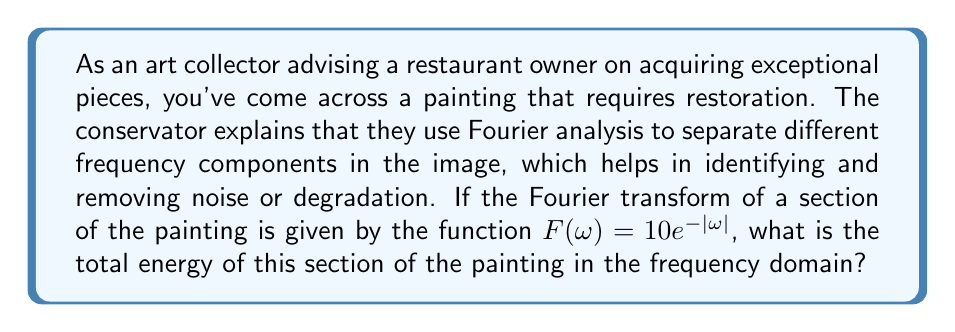Can you solve this math problem? To solve this problem, we need to understand and apply the concept of energy in the frequency domain using Fourier transforms. The steps are as follows:

1) The energy of a signal in the frequency domain is given by Parseval's theorem:

   $$E = \frac{1}{2\pi} \int_{-\infty}^{\infty} |F(\omega)|^2 d\omega$$

   where $F(\omega)$ is the Fourier transform of the signal.

2) In this case, $F(\omega) = 10e^{-|\omega|}$. We need to find $|F(\omega)|^2$:

   $$|F(\omega)|^2 = (10e^{-|\omega|})(10e^{-|\omega|}) = 100e^{-2|\omega|}$$

3) Now, we can set up our integral:

   $$E = \frac{1}{2\pi} \int_{-\infty}^{\infty} 100e^{-2|\omega|} d\omega$$

4) Due to the absolute value in the exponent, we can split this into two integrals:

   $$E = \frac{1}{2\pi} \left(\int_{-\infty}^{0} 100e^{2\omega} d\omega + \int_{0}^{\infty} 100e^{-2\omega} d\omega\right)$$

5) Let's solve these integrals:

   For $\int_{-\infty}^{0} 100e^{2\omega} d\omega$:
   $$\left. \frac{100}{2}e^{2\omega} \right|_{-\infty}^{0} = 50 - 0 = 50$$

   For $\int_{0}^{\infty} 100e^{-2\omega} d\omega$:
   $$\left. -\frac{100}{2}e^{-2\omega} \right|_{0}^{\infty} = 0 - (-50) = 50$$

6) Adding these results:

   $$E = \frac{1}{2\pi} (50 + 50) = \frac{100}{2\pi} = \frac{50}{\pi}$$

Thus, the total energy of this section of the painting in the frequency domain is $\frac{50}{\pi}$.
Answer: $\frac{50}{\pi}$ 